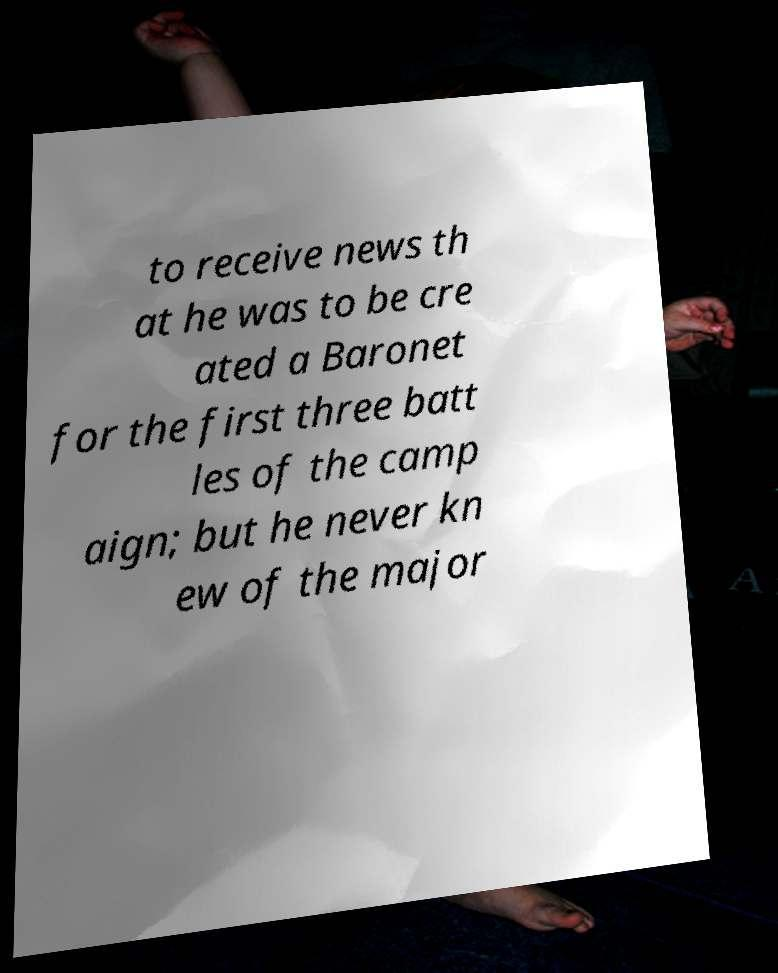There's text embedded in this image that I need extracted. Can you transcribe it verbatim? to receive news th at he was to be cre ated a Baronet for the first three batt les of the camp aign; but he never kn ew of the major 